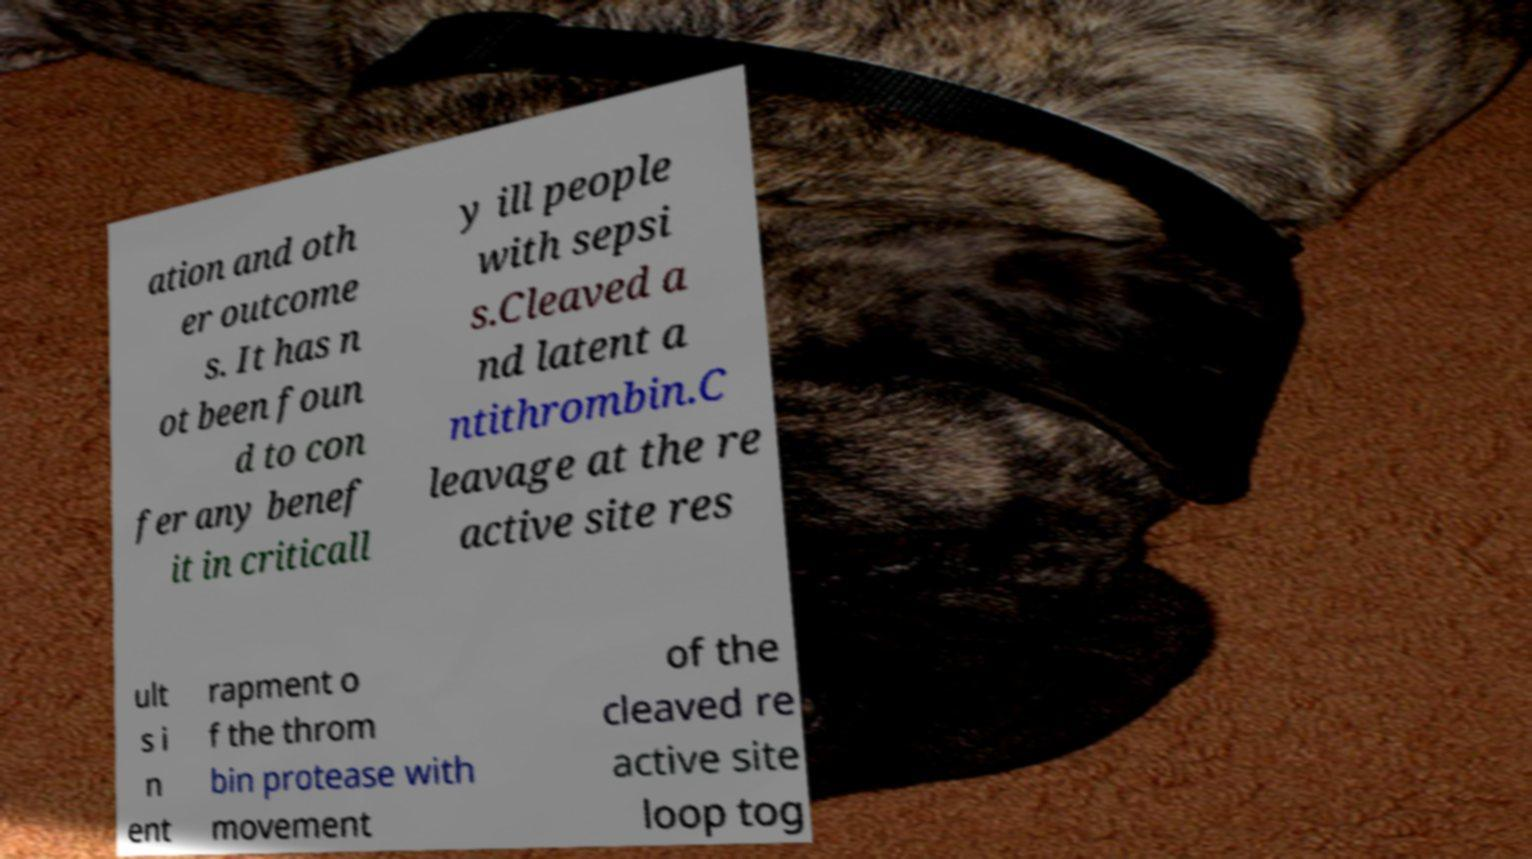Could you extract and type out the text from this image? ation and oth er outcome s. It has n ot been foun d to con fer any benef it in criticall y ill people with sepsi s.Cleaved a nd latent a ntithrombin.C leavage at the re active site res ult s i n ent rapment o f the throm bin protease with movement of the cleaved re active site loop tog 